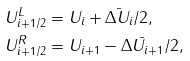<formula> <loc_0><loc_0><loc_500><loc_500>U ^ { L } _ { i + 1 / 2 } & = U _ { i } + \bar { \Delta U _ { i } } / 2 , \\ U ^ { R } _ { i + 1 / 2 } & = U _ { i + 1 } - \bar { \Delta U _ { i + 1 } } / 2 ,</formula> 